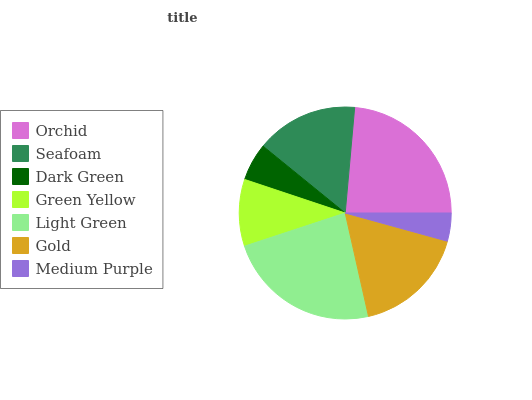Is Medium Purple the minimum?
Answer yes or no. Yes. Is Orchid the maximum?
Answer yes or no. Yes. Is Seafoam the minimum?
Answer yes or no. No. Is Seafoam the maximum?
Answer yes or no. No. Is Orchid greater than Seafoam?
Answer yes or no. Yes. Is Seafoam less than Orchid?
Answer yes or no. Yes. Is Seafoam greater than Orchid?
Answer yes or no. No. Is Orchid less than Seafoam?
Answer yes or no. No. Is Seafoam the high median?
Answer yes or no. Yes. Is Seafoam the low median?
Answer yes or no. Yes. Is Orchid the high median?
Answer yes or no. No. Is Orchid the low median?
Answer yes or no. No. 